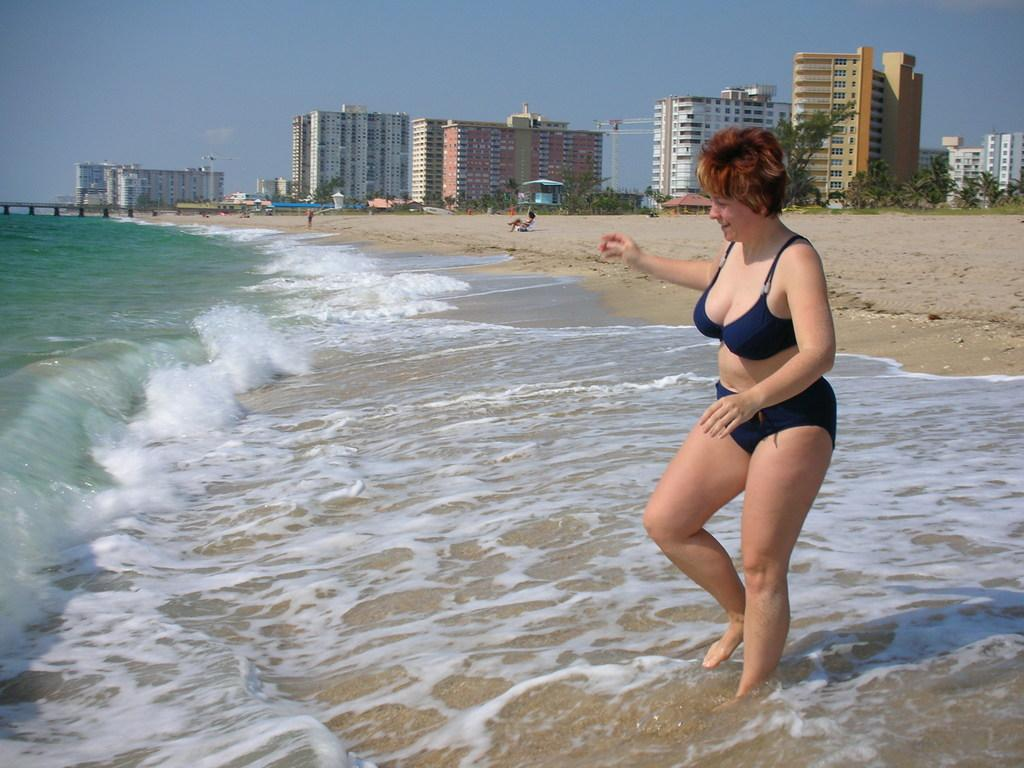Who is present in the image? There is a woman in the picture. What can be seen in the foreground of the image? Water is visible in the picture. What is visible in the background of the image? There are people, buildings, trees, and the sky visible in the background of the picture. Can you describe the unspecified objects in the background of the image? Unfortunately, the facts provided do not specify the nature of the unspecified objects in the background. Can you tell me how many fairies are flying around the woman in the image? There are no fairies present in the image; it only features a woman, water, and various background elements. 